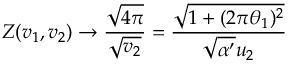Convert formula to latex. <formula><loc_0><loc_0><loc_500><loc_500>Z ( v _ { 1 } , v _ { 2 } ) \rightarrow \frac { \sqrt { 4 \pi } } { \sqrt { v _ { 2 } } } = \frac { \sqrt { 1 + ( 2 \pi \theta _ { 1 } ) ^ { 2 } } } { \sqrt { \alpha ^ { \prime } } u _ { 2 } }</formula> 